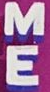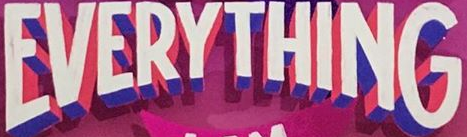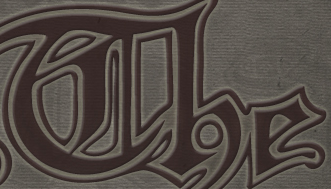Transcribe the words shown in these images in order, separated by a semicolon. ME; EVERYTHING; The 